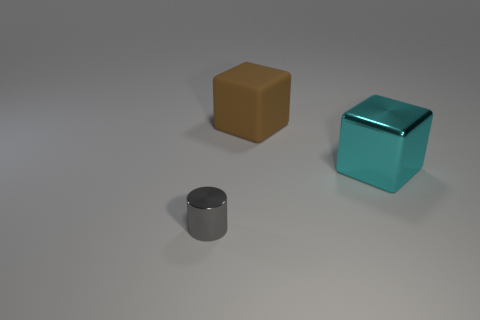Add 1 large gray metallic cubes. How many objects exist? 4 Subtract all cyan metallic cubes. Subtract all big red rubber cubes. How many objects are left? 2 Add 3 big cyan things. How many big cyan things are left? 4 Add 1 small red metallic cylinders. How many small red metallic cylinders exist? 1 Subtract 0 green blocks. How many objects are left? 3 Subtract all blocks. How many objects are left? 1 Subtract 1 blocks. How many blocks are left? 1 Subtract all red cylinders. Subtract all red cubes. How many cylinders are left? 1 Subtract all blue cylinders. How many brown blocks are left? 1 